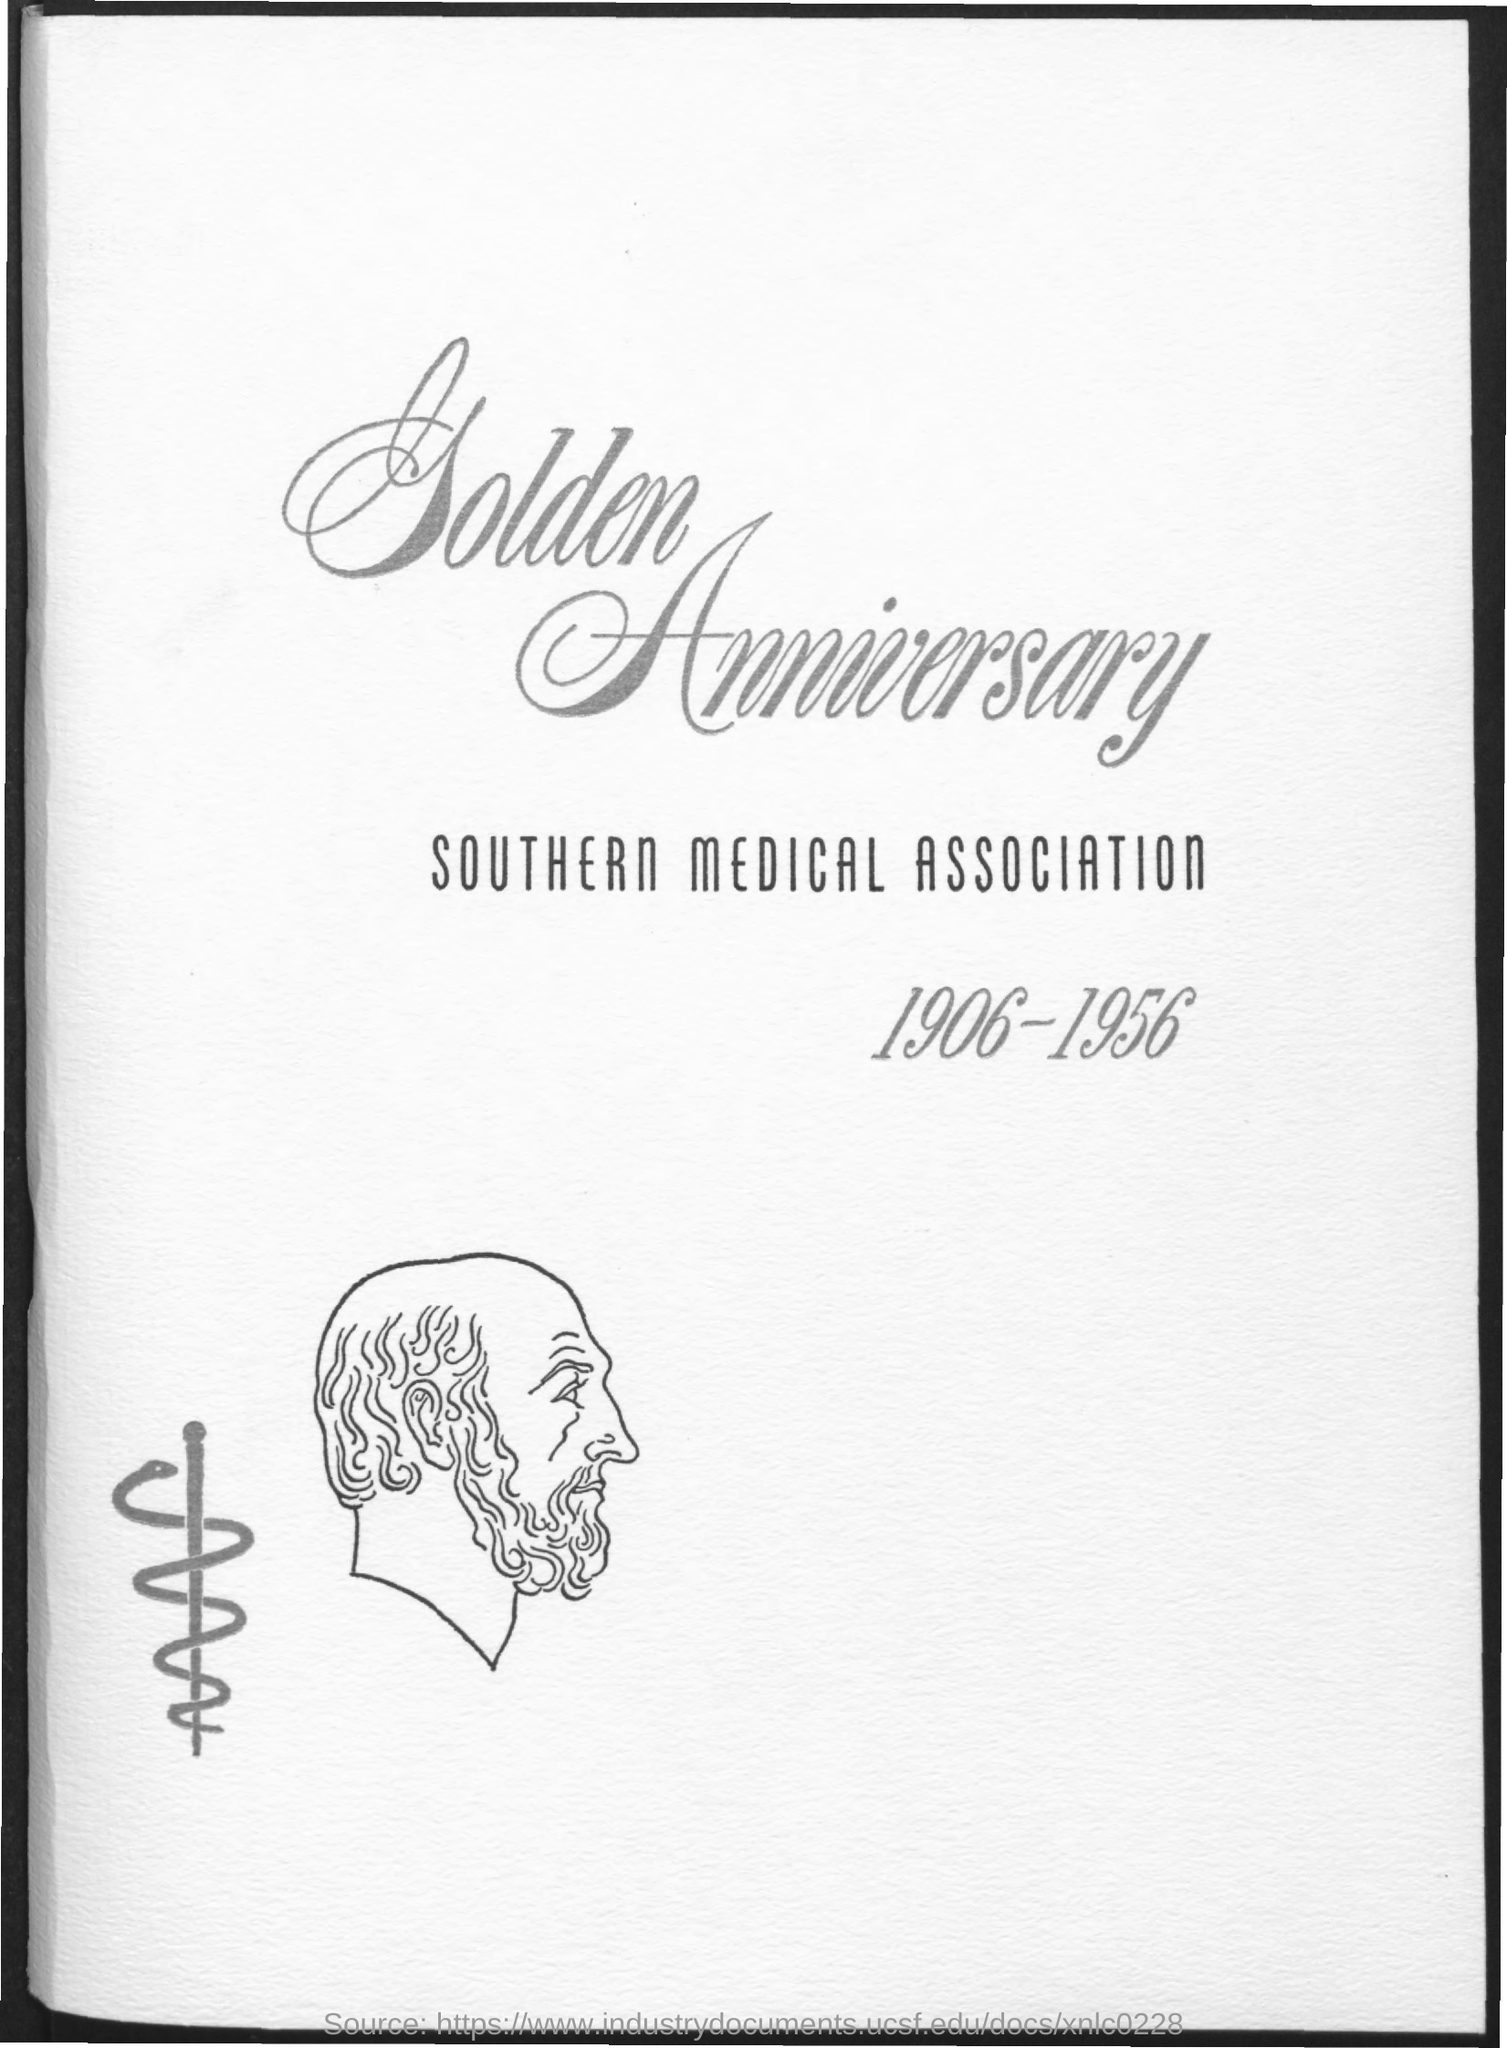What is the first title in the document?
Your answer should be compact. GOLDEN ANNIVERSARY. What is the second title in the document?
Offer a terse response. SOUTHERN MEDICAL ASSOCIATION. What is the range of years mentioned in the document ?
Your answer should be very brief. 1906-1956. 